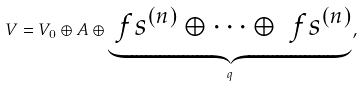<formula> <loc_0><loc_0><loc_500><loc_500>V = V _ { 0 } \oplus A \oplus \underbrace { \ f s ^ { ( n ) } \oplus \dots \oplus \ f s ^ { ( n ) } } _ { q } ,</formula> 